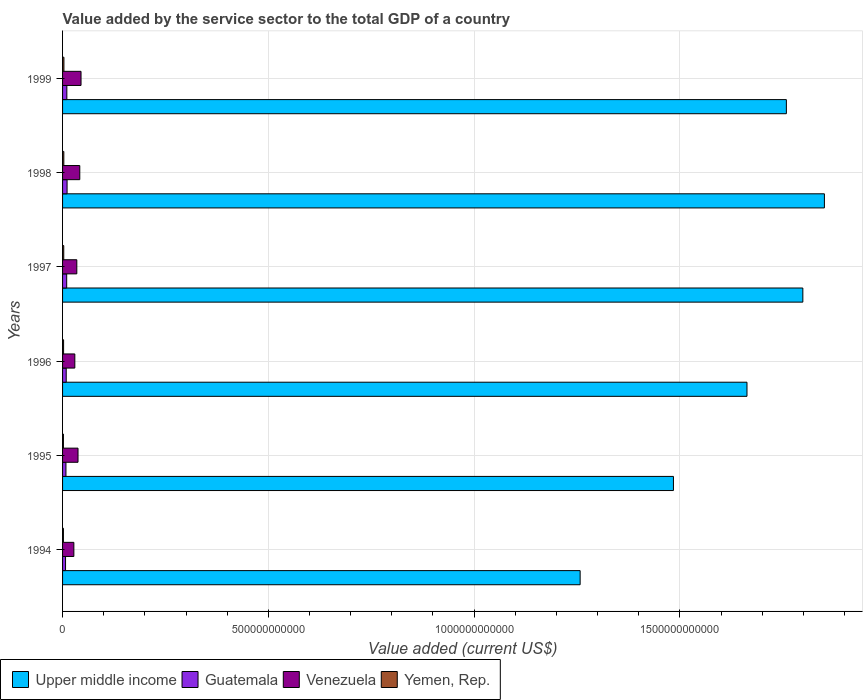Are the number of bars per tick equal to the number of legend labels?
Keep it short and to the point. Yes. What is the value added by the service sector to the total GDP in Venezuela in 1999?
Keep it short and to the point. 4.49e+1. Across all years, what is the maximum value added by the service sector to the total GDP in Guatemala?
Provide a succinct answer. 1.10e+1. Across all years, what is the minimum value added by the service sector to the total GDP in Guatemala?
Give a very brief answer. 7.25e+09. In which year was the value added by the service sector to the total GDP in Upper middle income maximum?
Ensure brevity in your answer.  1998. What is the total value added by the service sector to the total GDP in Yemen, Rep. in the graph?
Provide a short and direct response. 1.59e+1. What is the difference between the value added by the service sector to the total GDP in Yemen, Rep. in 1994 and that in 1996?
Make the answer very short. -4.10e+08. What is the difference between the value added by the service sector to the total GDP in Yemen, Rep. in 1997 and the value added by the service sector to the total GDP in Venezuela in 1999?
Offer a terse response. -4.20e+1. What is the average value added by the service sector to the total GDP in Guatemala per year?
Offer a very short reply. 9.29e+09. In the year 1997, what is the difference between the value added by the service sector to the total GDP in Yemen, Rep. and value added by the service sector to the total GDP in Venezuela?
Make the answer very short. -3.18e+1. In how many years, is the value added by the service sector to the total GDP in Venezuela greater than 1200000000000 US$?
Keep it short and to the point. 0. What is the ratio of the value added by the service sector to the total GDP in Yemen, Rep. in 1996 to that in 1999?
Provide a short and direct response. 0.76. Is the value added by the service sector to the total GDP in Yemen, Rep. in 1996 less than that in 1997?
Give a very brief answer. Yes. What is the difference between the highest and the second highest value added by the service sector to the total GDP in Venezuela?
Make the answer very short. 3.01e+09. What is the difference between the highest and the lowest value added by the service sector to the total GDP in Guatemala?
Provide a short and direct response. 3.72e+09. In how many years, is the value added by the service sector to the total GDP in Guatemala greater than the average value added by the service sector to the total GDP in Guatemala taken over all years?
Make the answer very short. 3. Is it the case that in every year, the sum of the value added by the service sector to the total GDP in Guatemala and value added by the service sector to the total GDP in Yemen, Rep. is greater than the sum of value added by the service sector to the total GDP in Venezuela and value added by the service sector to the total GDP in Upper middle income?
Ensure brevity in your answer.  No. What does the 1st bar from the top in 1999 represents?
Give a very brief answer. Yemen, Rep. What does the 3rd bar from the bottom in 1997 represents?
Provide a short and direct response. Venezuela. Is it the case that in every year, the sum of the value added by the service sector to the total GDP in Upper middle income and value added by the service sector to the total GDP in Yemen, Rep. is greater than the value added by the service sector to the total GDP in Guatemala?
Provide a succinct answer. Yes. How many bars are there?
Your answer should be compact. 24. Are all the bars in the graph horizontal?
Your response must be concise. Yes. How many years are there in the graph?
Make the answer very short. 6. What is the difference between two consecutive major ticks on the X-axis?
Ensure brevity in your answer.  5.00e+11. Are the values on the major ticks of X-axis written in scientific E-notation?
Keep it short and to the point. No. Does the graph contain grids?
Your response must be concise. Yes. How many legend labels are there?
Make the answer very short. 4. What is the title of the graph?
Your response must be concise. Value added by the service sector to the total GDP of a country. What is the label or title of the X-axis?
Provide a succinct answer. Value added (current US$). What is the label or title of the Y-axis?
Make the answer very short. Years. What is the Value added (current US$) of Upper middle income in 1994?
Offer a very short reply. 1.26e+12. What is the Value added (current US$) in Guatemala in 1994?
Give a very brief answer. 7.25e+09. What is the Value added (current US$) in Venezuela in 1994?
Your answer should be very brief. 2.74e+1. What is the Value added (current US$) of Yemen, Rep. in 1994?
Make the answer very short. 2.08e+09. What is the Value added (current US$) in Upper middle income in 1995?
Offer a terse response. 1.48e+12. What is the Value added (current US$) in Guatemala in 1995?
Offer a very short reply. 8.24e+09. What is the Value added (current US$) in Venezuela in 1995?
Offer a terse response. 3.76e+1. What is the Value added (current US$) in Yemen, Rep. in 1995?
Offer a terse response. 2.08e+09. What is the Value added (current US$) in Upper middle income in 1996?
Make the answer very short. 1.66e+12. What is the Value added (current US$) of Guatemala in 1996?
Provide a succinct answer. 8.88e+09. What is the Value added (current US$) in Venezuela in 1996?
Make the answer very short. 2.98e+1. What is the Value added (current US$) in Yemen, Rep. in 1996?
Make the answer very short. 2.49e+09. What is the Value added (current US$) of Upper middle income in 1997?
Your answer should be compact. 1.80e+12. What is the Value added (current US$) in Guatemala in 1997?
Your answer should be very brief. 1.00e+1. What is the Value added (current US$) in Venezuela in 1997?
Ensure brevity in your answer.  3.46e+1. What is the Value added (current US$) in Yemen, Rep. in 1997?
Your answer should be compact. 2.87e+09. What is the Value added (current US$) in Upper middle income in 1998?
Provide a succinct answer. 1.85e+12. What is the Value added (current US$) in Guatemala in 1998?
Provide a succinct answer. 1.10e+1. What is the Value added (current US$) in Venezuela in 1998?
Make the answer very short. 4.18e+1. What is the Value added (current US$) of Yemen, Rep. in 1998?
Keep it short and to the point. 3.06e+09. What is the Value added (current US$) in Upper middle income in 1999?
Keep it short and to the point. 1.76e+12. What is the Value added (current US$) of Guatemala in 1999?
Offer a terse response. 1.04e+1. What is the Value added (current US$) in Venezuela in 1999?
Keep it short and to the point. 4.49e+1. What is the Value added (current US$) in Yemen, Rep. in 1999?
Your answer should be compact. 3.28e+09. Across all years, what is the maximum Value added (current US$) of Upper middle income?
Your answer should be very brief. 1.85e+12. Across all years, what is the maximum Value added (current US$) of Guatemala?
Your answer should be compact. 1.10e+1. Across all years, what is the maximum Value added (current US$) of Venezuela?
Provide a succinct answer. 4.49e+1. Across all years, what is the maximum Value added (current US$) of Yemen, Rep.?
Make the answer very short. 3.28e+09. Across all years, what is the minimum Value added (current US$) in Upper middle income?
Offer a very short reply. 1.26e+12. Across all years, what is the minimum Value added (current US$) in Guatemala?
Your response must be concise. 7.25e+09. Across all years, what is the minimum Value added (current US$) in Venezuela?
Keep it short and to the point. 2.74e+1. Across all years, what is the minimum Value added (current US$) in Yemen, Rep.?
Keep it short and to the point. 2.08e+09. What is the total Value added (current US$) of Upper middle income in the graph?
Offer a terse response. 9.81e+12. What is the total Value added (current US$) in Guatemala in the graph?
Your answer should be very brief. 5.58e+1. What is the total Value added (current US$) in Venezuela in the graph?
Your answer should be compact. 2.16e+11. What is the total Value added (current US$) in Yemen, Rep. in the graph?
Your answer should be compact. 1.59e+1. What is the difference between the Value added (current US$) of Upper middle income in 1994 and that in 1995?
Provide a short and direct response. -2.27e+11. What is the difference between the Value added (current US$) in Guatemala in 1994 and that in 1995?
Your answer should be very brief. -9.87e+08. What is the difference between the Value added (current US$) in Venezuela in 1994 and that in 1995?
Make the answer very short. -1.01e+1. What is the difference between the Value added (current US$) in Yemen, Rep. in 1994 and that in 1995?
Your answer should be very brief. -3.26e+06. What is the difference between the Value added (current US$) in Upper middle income in 1994 and that in 1996?
Offer a terse response. -4.05e+11. What is the difference between the Value added (current US$) of Guatemala in 1994 and that in 1996?
Make the answer very short. -1.63e+09. What is the difference between the Value added (current US$) of Venezuela in 1994 and that in 1996?
Keep it short and to the point. -2.36e+09. What is the difference between the Value added (current US$) in Yemen, Rep. in 1994 and that in 1996?
Give a very brief answer. -4.10e+08. What is the difference between the Value added (current US$) in Upper middle income in 1994 and that in 1997?
Give a very brief answer. -5.41e+11. What is the difference between the Value added (current US$) of Guatemala in 1994 and that in 1997?
Offer a very short reply. -2.77e+09. What is the difference between the Value added (current US$) of Venezuela in 1994 and that in 1997?
Offer a terse response. -7.21e+09. What is the difference between the Value added (current US$) in Yemen, Rep. in 1994 and that in 1997?
Your response must be concise. -7.89e+08. What is the difference between the Value added (current US$) in Upper middle income in 1994 and that in 1998?
Your answer should be compact. -5.94e+11. What is the difference between the Value added (current US$) of Guatemala in 1994 and that in 1998?
Your answer should be compact. -3.72e+09. What is the difference between the Value added (current US$) in Venezuela in 1994 and that in 1998?
Offer a terse response. -1.44e+1. What is the difference between the Value added (current US$) in Yemen, Rep. in 1994 and that in 1998?
Your response must be concise. -9.82e+08. What is the difference between the Value added (current US$) of Upper middle income in 1994 and that in 1999?
Ensure brevity in your answer.  -5.01e+11. What is the difference between the Value added (current US$) of Guatemala in 1994 and that in 1999?
Make the answer very short. -3.16e+09. What is the difference between the Value added (current US$) in Venezuela in 1994 and that in 1999?
Your response must be concise. -1.74e+1. What is the difference between the Value added (current US$) in Yemen, Rep. in 1994 and that in 1999?
Your answer should be very brief. -1.20e+09. What is the difference between the Value added (current US$) in Upper middle income in 1995 and that in 1996?
Keep it short and to the point. -1.79e+11. What is the difference between the Value added (current US$) of Guatemala in 1995 and that in 1996?
Give a very brief answer. -6.43e+08. What is the difference between the Value added (current US$) of Venezuela in 1995 and that in 1996?
Your answer should be very brief. 7.78e+09. What is the difference between the Value added (current US$) of Yemen, Rep. in 1995 and that in 1996?
Make the answer very short. -4.07e+08. What is the difference between the Value added (current US$) of Upper middle income in 1995 and that in 1997?
Provide a succinct answer. -3.14e+11. What is the difference between the Value added (current US$) of Guatemala in 1995 and that in 1997?
Give a very brief answer. -1.78e+09. What is the difference between the Value added (current US$) in Venezuela in 1995 and that in 1997?
Make the answer very short. 2.93e+09. What is the difference between the Value added (current US$) of Yemen, Rep. in 1995 and that in 1997?
Provide a succinct answer. -7.86e+08. What is the difference between the Value added (current US$) of Upper middle income in 1995 and that in 1998?
Make the answer very short. -3.67e+11. What is the difference between the Value added (current US$) in Guatemala in 1995 and that in 1998?
Offer a very short reply. -2.73e+09. What is the difference between the Value added (current US$) of Venezuela in 1995 and that in 1998?
Ensure brevity in your answer.  -4.28e+09. What is the difference between the Value added (current US$) of Yemen, Rep. in 1995 and that in 1998?
Your response must be concise. -9.78e+08. What is the difference between the Value added (current US$) of Upper middle income in 1995 and that in 1999?
Your response must be concise. -2.74e+11. What is the difference between the Value added (current US$) of Guatemala in 1995 and that in 1999?
Give a very brief answer. -2.17e+09. What is the difference between the Value added (current US$) of Venezuela in 1995 and that in 1999?
Make the answer very short. -7.29e+09. What is the difference between the Value added (current US$) of Yemen, Rep. in 1995 and that in 1999?
Ensure brevity in your answer.  -1.20e+09. What is the difference between the Value added (current US$) in Upper middle income in 1996 and that in 1997?
Your answer should be compact. -1.36e+11. What is the difference between the Value added (current US$) in Guatemala in 1996 and that in 1997?
Your response must be concise. -1.14e+09. What is the difference between the Value added (current US$) of Venezuela in 1996 and that in 1997?
Provide a short and direct response. -4.85e+09. What is the difference between the Value added (current US$) in Yemen, Rep. in 1996 and that in 1997?
Ensure brevity in your answer.  -3.79e+08. What is the difference between the Value added (current US$) of Upper middle income in 1996 and that in 1998?
Offer a very short reply. -1.88e+11. What is the difference between the Value added (current US$) in Guatemala in 1996 and that in 1998?
Offer a terse response. -2.09e+09. What is the difference between the Value added (current US$) in Venezuela in 1996 and that in 1998?
Offer a terse response. -1.21e+1. What is the difference between the Value added (current US$) in Yemen, Rep. in 1996 and that in 1998?
Offer a very short reply. -5.72e+08. What is the difference between the Value added (current US$) of Upper middle income in 1996 and that in 1999?
Your answer should be very brief. -9.57e+1. What is the difference between the Value added (current US$) of Guatemala in 1996 and that in 1999?
Provide a short and direct response. -1.53e+09. What is the difference between the Value added (current US$) in Venezuela in 1996 and that in 1999?
Provide a succinct answer. -1.51e+1. What is the difference between the Value added (current US$) of Yemen, Rep. in 1996 and that in 1999?
Ensure brevity in your answer.  -7.93e+08. What is the difference between the Value added (current US$) in Upper middle income in 1997 and that in 1998?
Keep it short and to the point. -5.24e+1. What is the difference between the Value added (current US$) of Guatemala in 1997 and that in 1998?
Your answer should be compact. -9.55e+08. What is the difference between the Value added (current US$) in Venezuela in 1997 and that in 1998?
Provide a short and direct response. -7.21e+09. What is the difference between the Value added (current US$) in Yemen, Rep. in 1997 and that in 1998?
Your answer should be very brief. -1.93e+08. What is the difference between the Value added (current US$) of Upper middle income in 1997 and that in 1999?
Provide a succinct answer. 4.00e+1. What is the difference between the Value added (current US$) in Guatemala in 1997 and that in 1999?
Your answer should be very brief. -3.96e+08. What is the difference between the Value added (current US$) of Venezuela in 1997 and that in 1999?
Provide a succinct answer. -1.02e+1. What is the difference between the Value added (current US$) of Yemen, Rep. in 1997 and that in 1999?
Your response must be concise. -4.14e+08. What is the difference between the Value added (current US$) of Upper middle income in 1998 and that in 1999?
Offer a terse response. 9.24e+1. What is the difference between the Value added (current US$) of Guatemala in 1998 and that in 1999?
Provide a short and direct response. 5.60e+08. What is the difference between the Value added (current US$) in Venezuela in 1998 and that in 1999?
Your response must be concise. -3.01e+09. What is the difference between the Value added (current US$) of Yemen, Rep. in 1998 and that in 1999?
Offer a terse response. -2.22e+08. What is the difference between the Value added (current US$) in Upper middle income in 1994 and the Value added (current US$) in Guatemala in 1995?
Your answer should be compact. 1.25e+12. What is the difference between the Value added (current US$) of Upper middle income in 1994 and the Value added (current US$) of Venezuela in 1995?
Offer a very short reply. 1.22e+12. What is the difference between the Value added (current US$) in Upper middle income in 1994 and the Value added (current US$) in Yemen, Rep. in 1995?
Your answer should be compact. 1.26e+12. What is the difference between the Value added (current US$) of Guatemala in 1994 and the Value added (current US$) of Venezuela in 1995?
Your response must be concise. -3.03e+1. What is the difference between the Value added (current US$) of Guatemala in 1994 and the Value added (current US$) of Yemen, Rep. in 1995?
Offer a very short reply. 5.17e+09. What is the difference between the Value added (current US$) in Venezuela in 1994 and the Value added (current US$) in Yemen, Rep. in 1995?
Provide a succinct answer. 2.53e+1. What is the difference between the Value added (current US$) in Upper middle income in 1994 and the Value added (current US$) in Guatemala in 1996?
Ensure brevity in your answer.  1.25e+12. What is the difference between the Value added (current US$) of Upper middle income in 1994 and the Value added (current US$) of Venezuela in 1996?
Give a very brief answer. 1.23e+12. What is the difference between the Value added (current US$) of Upper middle income in 1994 and the Value added (current US$) of Yemen, Rep. in 1996?
Offer a very short reply. 1.26e+12. What is the difference between the Value added (current US$) in Guatemala in 1994 and the Value added (current US$) in Venezuela in 1996?
Make the answer very short. -2.25e+1. What is the difference between the Value added (current US$) of Guatemala in 1994 and the Value added (current US$) of Yemen, Rep. in 1996?
Your answer should be very brief. 4.76e+09. What is the difference between the Value added (current US$) in Venezuela in 1994 and the Value added (current US$) in Yemen, Rep. in 1996?
Provide a short and direct response. 2.49e+1. What is the difference between the Value added (current US$) of Upper middle income in 1994 and the Value added (current US$) of Guatemala in 1997?
Offer a terse response. 1.25e+12. What is the difference between the Value added (current US$) of Upper middle income in 1994 and the Value added (current US$) of Venezuela in 1997?
Keep it short and to the point. 1.22e+12. What is the difference between the Value added (current US$) in Upper middle income in 1994 and the Value added (current US$) in Yemen, Rep. in 1997?
Give a very brief answer. 1.25e+12. What is the difference between the Value added (current US$) of Guatemala in 1994 and the Value added (current US$) of Venezuela in 1997?
Your response must be concise. -2.74e+1. What is the difference between the Value added (current US$) of Guatemala in 1994 and the Value added (current US$) of Yemen, Rep. in 1997?
Ensure brevity in your answer.  4.38e+09. What is the difference between the Value added (current US$) of Venezuela in 1994 and the Value added (current US$) of Yemen, Rep. in 1997?
Make the answer very short. 2.46e+1. What is the difference between the Value added (current US$) of Upper middle income in 1994 and the Value added (current US$) of Guatemala in 1998?
Provide a short and direct response. 1.25e+12. What is the difference between the Value added (current US$) in Upper middle income in 1994 and the Value added (current US$) in Venezuela in 1998?
Ensure brevity in your answer.  1.22e+12. What is the difference between the Value added (current US$) in Upper middle income in 1994 and the Value added (current US$) in Yemen, Rep. in 1998?
Make the answer very short. 1.25e+12. What is the difference between the Value added (current US$) of Guatemala in 1994 and the Value added (current US$) of Venezuela in 1998?
Your answer should be compact. -3.46e+1. What is the difference between the Value added (current US$) in Guatemala in 1994 and the Value added (current US$) in Yemen, Rep. in 1998?
Offer a very short reply. 4.19e+09. What is the difference between the Value added (current US$) of Venezuela in 1994 and the Value added (current US$) of Yemen, Rep. in 1998?
Keep it short and to the point. 2.44e+1. What is the difference between the Value added (current US$) in Upper middle income in 1994 and the Value added (current US$) in Guatemala in 1999?
Give a very brief answer. 1.25e+12. What is the difference between the Value added (current US$) of Upper middle income in 1994 and the Value added (current US$) of Venezuela in 1999?
Offer a very short reply. 1.21e+12. What is the difference between the Value added (current US$) of Upper middle income in 1994 and the Value added (current US$) of Yemen, Rep. in 1999?
Give a very brief answer. 1.25e+12. What is the difference between the Value added (current US$) of Guatemala in 1994 and the Value added (current US$) of Venezuela in 1999?
Make the answer very short. -3.76e+1. What is the difference between the Value added (current US$) in Guatemala in 1994 and the Value added (current US$) in Yemen, Rep. in 1999?
Offer a very short reply. 3.97e+09. What is the difference between the Value added (current US$) of Venezuela in 1994 and the Value added (current US$) of Yemen, Rep. in 1999?
Your answer should be very brief. 2.41e+1. What is the difference between the Value added (current US$) of Upper middle income in 1995 and the Value added (current US$) of Guatemala in 1996?
Make the answer very short. 1.48e+12. What is the difference between the Value added (current US$) of Upper middle income in 1995 and the Value added (current US$) of Venezuela in 1996?
Your response must be concise. 1.45e+12. What is the difference between the Value added (current US$) in Upper middle income in 1995 and the Value added (current US$) in Yemen, Rep. in 1996?
Provide a short and direct response. 1.48e+12. What is the difference between the Value added (current US$) in Guatemala in 1995 and the Value added (current US$) in Venezuela in 1996?
Give a very brief answer. -2.15e+1. What is the difference between the Value added (current US$) in Guatemala in 1995 and the Value added (current US$) in Yemen, Rep. in 1996?
Your answer should be very brief. 5.75e+09. What is the difference between the Value added (current US$) of Venezuela in 1995 and the Value added (current US$) of Yemen, Rep. in 1996?
Provide a short and direct response. 3.51e+1. What is the difference between the Value added (current US$) in Upper middle income in 1995 and the Value added (current US$) in Guatemala in 1997?
Give a very brief answer. 1.47e+12. What is the difference between the Value added (current US$) of Upper middle income in 1995 and the Value added (current US$) of Venezuela in 1997?
Your response must be concise. 1.45e+12. What is the difference between the Value added (current US$) in Upper middle income in 1995 and the Value added (current US$) in Yemen, Rep. in 1997?
Offer a very short reply. 1.48e+12. What is the difference between the Value added (current US$) of Guatemala in 1995 and the Value added (current US$) of Venezuela in 1997?
Keep it short and to the point. -2.64e+1. What is the difference between the Value added (current US$) in Guatemala in 1995 and the Value added (current US$) in Yemen, Rep. in 1997?
Give a very brief answer. 5.37e+09. What is the difference between the Value added (current US$) of Venezuela in 1995 and the Value added (current US$) of Yemen, Rep. in 1997?
Your response must be concise. 3.47e+1. What is the difference between the Value added (current US$) of Upper middle income in 1995 and the Value added (current US$) of Guatemala in 1998?
Your answer should be very brief. 1.47e+12. What is the difference between the Value added (current US$) in Upper middle income in 1995 and the Value added (current US$) in Venezuela in 1998?
Your response must be concise. 1.44e+12. What is the difference between the Value added (current US$) of Upper middle income in 1995 and the Value added (current US$) of Yemen, Rep. in 1998?
Offer a very short reply. 1.48e+12. What is the difference between the Value added (current US$) of Guatemala in 1995 and the Value added (current US$) of Venezuela in 1998?
Make the answer very short. -3.36e+1. What is the difference between the Value added (current US$) of Guatemala in 1995 and the Value added (current US$) of Yemen, Rep. in 1998?
Your response must be concise. 5.17e+09. What is the difference between the Value added (current US$) in Venezuela in 1995 and the Value added (current US$) in Yemen, Rep. in 1998?
Your response must be concise. 3.45e+1. What is the difference between the Value added (current US$) in Upper middle income in 1995 and the Value added (current US$) in Guatemala in 1999?
Your answer should be very brief. 1.47e+12. What is the difference between the Value added (current US$) in Upper middle income in 1995 and the Value added (current US$) in Venezuela in 1999?
Make the answer very short. 1.44e+12. What is the difference between the Value added (current US$) of Upper middle income in 1995 and the Value added (current US$) of Yemen, Rep. in 1999?
Give a very brief answer. 1.48e+12. What is the difference between the Value added (current US$) of Guatemala in 1995 and the Value added (current US$) of Venezuela in 1999?
Your answer should be very brief. -3.66e+1. What is the difference between the Value added (current US$) in Guatemala in 1995 and the Value added (current US$) in Yemen, Rep. in 1999?
Give a very brief answer. 4.95e+09. What is the difference between the Value added (current US$) of Venezuela in 1995 and the Value added (current US$) of Yemen, Rep. in 1999?
Make the answer very short. 3.43e+1. What is the difference between the Value added (current US$) of Upper middle income in 1996 and the Value added (current US$) of Guatemala in 1997?
Provide a succinct answer. 1.65e+12. What is the difference between the Value added (current US$) of Upper middle income in 1996 and the Value added (current US$) of Venezuela in 1997?
Make the answer very short. 1.63e+12. What is the difference between the Value added (current US$) in Upper middle income in 1996 and the Value added (current US$) in Yemen, Rep. in 1997?
Your response must be concise. 1.66e+12. What is the difference between the Value added (current US$) in Guatemala in 1996 and the Value added (current US$) in Venezuela in 1997?
Give a very brief answer. -2.58e+1. What is the difference between the Value added (current US$) of Guatemala in 1996 and the Value added (current US$) of Yemen, Rep. in 1997?
Your response must be concise. 6.01e+09. What is the difference between the Value added (current US$) in Venezuela in 1996 and the Value added (current US$) in Yemen, Rep. in 1997?
Your answer should be compact. 2.69e+1. What is the difference between the Value added (current US$) in Upper middle income in 1996 and the Value added (current US$) in Guatemala in 1998?
Offer a very short reply. 1.65e+12. What is the difference between the Value added (current US$) of Upper middle income in 1996 and the Value added (current US$) of Venezuela in 1998?
Offer a terse response. 1.62e+12. What is the difference between the Value added (current US$) in Upper middle income in 1996 and the Value added (current US$) in Yemen, Rep. in 1998?
Give a very brief answer. 1.66e+12. What is the difference between the Value added (current US$) of Guatemala in 1996 and the Value added (current US$) of Venezuela in 1998?
Your answer should be very brief. -3.30e+1. What is the difference between the Value added (current US$) in Guatemala in 1996 and the Value added (current US$) in Yemen, Rep. in 1998?
Offer a terse response. 5.82e+09. What is the difference between the Value added (current US$) of Venezuela in 1996 and the Value added (current US$) of Yemen, Rep. in 1998?
Offer a terse response. 2.67e+1. What is the difference between the Value added (current US$) in Upper middle income in 1996 and the Value added (current US$) in Guatemala in 1999?
Provide a succinct answer. 1.65e+12. What is the difference between the Value added (current US$) of Upper middle income in 1996 and the Value added (current US$) of Venezuela in 1999?
Offer a terse response. 1.62e+12. What is the difference between the Value added (current US$) in Upper middle income in 1996 and the Value added (current US$) in Yemen, Rep. in 1999?
Your response must be concise. 1.66e+12. What is the difference between the Value added (current US$) of Guatemala in 1996 and the Value added (current US$) of Venezuela in 1999?
Provide a short and direct response. -3.60e+1. What is the difference between the Value added (current US$) of Guatemala in 1996 and the Value added (current US$) of Yemen, Rep. in 1999?
Offer a very short reply. 5.60e+09. What is the difference between the Value added (current US$) in Venezuela in 1996 and the Value added (current US$) in Yemen, Rep. in 1999?
Your response must be concise. 2.65e+1. What is the difference between the Value added (current US$) in Upper middle income in 1997 and the Value added (current US$) in Guatemala in 1998?
Keep it short and to the point. 1.79e+12. What is the difference between the Value added (current US$) in Upper middle income in 1997 and the Value added (current US$) in Venezuela in 1998?
Provide a short and direct response. 1.76e+12. What is the difference between the Value added (current US$) in Upper middle income in 1997 and the Value added (current US$) in Yemen, Rep. in 1998?
Provide a short and direct response. 1.80e+12. What is the difference between the Value added (current US$) of Guatemala in 1997 and the Value added (current US$) of Venezuela in 1998?
Provide a short and direct response. -3.18e+1. What is the difference between the Value added (current US$) in Guatemala in 1997 and the Value added (current US$) in Yemen, Rep. in 1998?
Offer a very short reply. 6.95e+09. What is the difference between the Value added (current US$) in Venezuela in 1997 and the Value added (current US$) in Yemen, Rep. in 1998?
Your answer should be compact. 3.16e+1. What is the difference between the Value added (current US$) of Upper middle income in 1997 and the Value added (current US$) of Guatemala in 1999?
Your answer should be very brief. 1.79e+12. What is the difference between the Value added (current US$) in Upper middle income in 1997 and the Value added (current US$) in Venezuela in 1999?
Give a very brief answer. 1.75e+12. What is the difference between the Value added (current US$) of Upper middle income in 1997 and the Value added (current US$) of Yemen, Rep. in 1999?
Make the answer very short. 1.80e+12. What is the difference between the Value added (current US$) of Guatemala in 1997 and the Value added (current US$) of Venezuela in 1999?
Keep it short and to the point. -3.48e+1. What is the difference between the Value added (current US$) in Guatemala in 1997 and the Value added (current US$) in Yemen, Rep. in 1999?
Provide a succinct answer. 6.73e+09. What is the difference between the Value added (current US$) in Venezuela in 1997 and the Value added (current US$) in Yemen, Rep. in 1999?
Your answer should be very brief. 3.13e+1. What is the difference between the Value added (current US$) in Upper middle income in 1998 and the Value added (current US$) in Guatemala in 1999?
Offer a terse response. 1.84e+12. What is the difference between the Value added (current US$) of Upper middle income in 1998 and the Value added (current US$) of Venezuela in 1999?
Your answer should be very brief. 1.81e+12. What is the difference between the Value added (current US$) of Upper middle income in 1998 and the Value added (current US$) of Yemen, Rep. in 1999?
Ensure brevity in your answer.  1.85e+12. What is the difference between the Value added (current US$) of Guatemala in 1998 and the Value added (current US$) of Venezuela in 1999?
Keep it short and to the point. -3.39e+1. What is the difference between the Value added (current US$) of Guatemala in 1998 and the Value added (current US$) of Yemen, Rep. in 1999?
Your answer should be very brief. 7.69e+09. What is the difference between the Value added (current US$) in Venezuela in 1998 and the Value added (current US$) in Yemen, Rep. in 1999?
Offer a very short reply. 3.86e+1. What is the average Value added (current US$) of Upper middle income per year?
Give a very brief answer. 1.64e+12. What is the average Value added (current US$) in Guatemala per year?
Keep it short and to the point. 9.29e+09. What is the average Value added (current US$) of Venezuela per year?
Provide a succinct answer. 3.60e+1. What is the average Value added (current US$) of Yemen, Rep. per year?
Your response must be concise. 2.64e+09. In the year 1994, what is the difference between the Value added (current US$) in Upper middle income and Value added (current US$) in Guatemala?
Your answer should be very brief. 1.25e+12. In the year 1994, what is the difference between the Value added (current US$) in Upper middle income and Value added (current US$) in Venezuela?
Your response must be concise. 1.23e+12. In the year 1994, what is the difference between the Value added (current US$) of Upper middle income and Value added (current US$) of Yemen, Rep.?
Offer a terse response. 1.26e+12. In the year 1994, what is the difference between the Value added (current US$) in Guatemala and Value added (current US$) in Venezuela?
Provide a short and direct response. -2.02e+1. In the year 1994, what is the difference between the Value added (current US$) of Guatemala and Value added (current US$) of Yemen, Rep.?
Make the answer very short. 5.17e+09. In the year 1994, what is the difference between the Value added (current US$) of Venezuela and Value added (current US$) of Yemen, Rep.?
Make the answer very short. 2.53e+1. In the year 1995, what is the difference between the Value added (current US$) in Upper middle income and Value added (current US$) in Guatemala?
Provide a succinct answer. 1.48e+12. In the year 1995, what is the difference between the Value added (current US$) in Upper middle income and Value added (current US$) in Venezuela?
Provide a succinct answer. 1.45e+12. In the year 1995, what is the difference between the Value added (current US$) of Upper middle income and Value added (current US$) of Yemen, Rep.?
Make the answer very short. 1.48e+12. In the year 1995, what is the difference between the Value added (current US$) of Guatemala and Value added (current US$) of Venezuela?
Provide a succinct answer. -2.93e+1. In the year 1995, what is the difference between the Value added (current US$) in Guatemala and Value added (current US$) in Yemen, Rep.?
Offer a very short reply. 6.15e+09. In the year 1995, what is the difference between the Value added (current US$) in Venezuela and Value added (current US$) in Yemen, Rep.?
Ensure brevity in your answer.  3.55e+1. In the year 1996, what is the difference between the Value added (current US$) of Upper middle income and Value added (current US$) of Guatemala?
Provide a succinct answer. 1.65e+12. In the year 1996, what is the difference between the Value added (current US$) in Upper middle income and Value added (current US$) in Venezuela?
Your answer should be compact. 1.63e+12. In the year 1996, what is the difference between the Value added (current US$) of Upper middle income and Value added (current US$) of Yemen, Rep.?
Your response must be concise. 1.66e+12. In the year 1996, what is the difference between the Value added (current US$) in Guatemala and Value added (current US$) in Venezuela?
Your response must be concise. -2.09e+1. In the year 1996, what is the difference between the Value added (current US$) in Guatemala and Value added (current US$) in Yemen, Rep.?
Give a very brief answer. 6.39e+09. In the year 1996, what is the difference between the Value added (current US$) of Venezuela and Value added (current US$) of Yemen, Rep.?
Your response must be concise. 2.73e+1. In the year 1997, what is the difference between the Value added (current US$) in Upper middle income and Value added (current US$) in Guatemala?
Give a very brief answer. 1.79e+12. In the year 1997, what is the difference between the Value added (current US$) in Upper middle income and Value added (current US$) in Venezuela?
Make the answer very short. 1.76e+12. In the year 1997, what is the difference between the Value added (current US$) in Upper middle income and Value added (current US$) in Yemen, Rep.?
Make the answer very short. 1.80e+12. In the year 1997, what is the difference between the Value added (current US$) of Guatemala and Value added (current US$) of Venezuela?
Offer a very short reply. -2.46e+1. In the year 1997, what is the difference between the Value added (current US$) of Guatemala and Value added (current US$) of Yemen, Rep.?
Make the answer very short. 7.15e+09. In the year 1997, what is the difference between the Value added (current US$) in Venezuela and Value added (current US$) in Yemen, Rep.?
Your answer should be compact. 3.18e+1. In the year 1998, what is the difference between the Value added (current US$) of Upper middle income and Value added (current US$) of Guatemala?
Your answer should be compact. 1.84e+12. In the year 1998, what is the difference between the Value added (current US$) of Upper middle income and Value added (current US$) of Venezuela?
Your answer should be very brief. 1.81e+12. In the year 1998, what is the difference between the Value added (current US$) of Upper middle income and Value added (current US$) of Yemen, Rep.?
Ensure brevity in your answer.  1.85e+12. In the year 1998, what is the difference between the Value added (current US$) of Guatemala and Value added (current US$) of Venezuela?
Offer a terse response. -3.09e+1. In the year 1998, what is the difference between the Value added (current US$) in Guatemala and Value added (current US$) in Yemen, Rep.?
Keep it short and to the point. 7.91e+09. In the year 1998, what is the difference between the Value added (current US$) in Venezuela and Value added (current US$) in Yemen, Rep.?
Offer a very short reply. 3.88e+1. In the year 1999, what is the difference between the Value added (current US$) in Upper middle income and Value added (current US$) in Guatemala?
Provide a succinct answer. 1.75e+12. In the year 1999, what is the difference between the Value added (current US$) in Upper middle income and Value added (current US$) in Venezuela?
Your response must be concise. 1.71e+12. In the year 1999, what is the difference between the Value added (current US$) of Upper middle income and Value added (current US$) of Yemen, Rep.?
Provide a succinct answer. 1.76e+12. In the year 1999, what is the difference between the Value added (current US$) of Guatemala and Value added (current US$) of Venezuela?
Ensure brevity in your answer.  -3.44e+1. In the year 1999, what is the difference between the Value added (current US$) of Guatemala and Value added (current US$) of Yemen, Rep.?
Offer a very short reply. 7.13e+09. In the year 1999, what is the difference between the Value added (current US$) of Venezuela and Value added (current US$) of Yemen, Rep.?
Make the answer very short. 4.16e+1. What is the ratio of the Value added (current US$) in Upper middle income in 1994 to that in 1995?
Your response must be concise. 0.85. What is the ratio of the Value added (current US$) of Guatemala in 1994 to that in 1995?
Give a very brief answer. 0.88. What is the ratio of the Value added (current US$) in Venezuela in 1994 to that in 1995?
Offer a very short reply. 0.73. What is the ratio of the Value added (current US$) in Yemen, Rep. in 1994 to that in 1995?
Provide a succinct answer. 1. What is the ratio of the Value added (current US$) of Upper middle income in 1994 to that in 1996?
Offer a very short reply. 0.76. What is the ratio of the Value added (current US$) in Guatemala in 1994 to that in 1996?
Keep it short and to the point. 0.82. What is the ratio of the Value added (current US$) in Venezuela in 1994 to that in 1996?
Keep it short and to the point. 0.92. What is the ratio of the Value added (current US$) of Yemen, Rep. in 1994 to that in 1996?
Keep it short and to the point. 0.84. What is the ratio of the Value added (current US$) of Upper middle income in 1994 to that in 1997?
Your answer should be very brief. 0.7. What is the ratio of the Value added (current US$) of Guatemala in 1994 to that in 1997?
Give a very brief answer. 0.72. What is the ratio of the Value added (current US$) in Venezuela in 1994 to that in 1997?
Provide a succinct answer. 0.79. What is the ratio of the Value added (current US$) of Yemen, Rep. in 1994 to that in 1997?
Your answer should be compact. 0.72. What is the ratio of the Value added (current US$) in Upper middle income in 1994 to that in 1998?
Your response must be concise. 0.68. What is the ratio of the Value added (current US$) of Guatemala in 1994 to that in 1998?
Offer a very short reply. 0.66. What is the ratio of the Value added (current US$) of Venezuela in 1994 to that in 1998?
Give a very brief answer. 0.66. What is the ratio of the Value added (current US$) in Yemen, Rep. in 1994 to that in 1998?
Ensure brevity in your answer.  0.68. What is the ratio of the Value added (current US$) in Upper middle income in 1994 to that in 1999?
Provide a short and direct response. 0.72. What is the ratio of the Value added (current US$) in Guatemala in 1994 to that in 1999?
Give a very brief answer. 0.7. What is the ratio of the Value added (current US$) in Venezuela in 1994 to that in 1999?
Ensure brevity in your answer.  0.61. What is the ratio of the Value added (current US$) of Yemen, Rep. in 1994 to that in 1999?
Ensure brevity in your answer.  0.63. What is the ratio of the Value added (current US$) in Upper middle income in 1995 to that in 1996?
Your answer should be very brief. 0.89. What is the ratio of the Value added (current US$) in Guatemala in 1995 to that in 1996?
Provide a succinct answer. 0.93. What is the ratio of the Value added (current US$) of Venezuela in 1995 to that in 1996?
Make the answer very short. 1.26. What is the ratio of the Value added (current US$) of Yemen, Rep. in 1995 to that in 1996?
Your answer should be compact. 0.84. What is the ratio of the Value added (current US$) of Upper middle income in 1995 to that in 1997?
Offer a terse response. 0.83. What is the ratio of the Value added (current US$) in Guatemala in 1995 to that in 1997?
Offer a very short reply. 0.82. What is the ratio of the Value added (current US$) in Venezuela in 1995 to that in 1997?
Provide a succinct answer. 1.08. What is the ratio of the Value added (current US$) in Yemen, Rep. in 1995 to that in 1997?
Your answer should be very brief. 0.73. What is the ratio of the Value added (current US$) in Upper middle income in 1995 to that in 1998?
Make the answer very short. 0.8. What is the ratio of the Value added (current US$) of Guatemala in 1995 to that in 1998?
Your answer should be very brief. 0.75. What is the ratio of the Value added (current US$) of Venezuela in 1995 to that in 1998?
Give a very brief answer. 0.9. What is the ratio of the Value added (current US$) in Yemen, Rep. in 1995 to that in 1998?
Your response must be concise. 0.68. What is the ratio of the Value added (current US$) in Upper middle income in 1995 to that in 1999?
Ensure brevity in your answer.  0.84. What is the ratio of the Value added (current US$) of Guatemala in 1995 to that in 1999?
Provide a succinct answer. 0.79. What is the ratio of the Value added (current US$) of Venezuela in 1995 to that in 1999?
Offer a very short reply. 0.84. What is the ratio of the Value added (current US$) in Yemen, Rep. in 1995 to that in 1999?
Provide a short and direct response. 0.63. What is the ratio of the Value added (current US$) in Upper middle income in 1996 to that in 1997?
Provide a succinct answer. 0.92. What is the ratio of the Value added (current US$) of Guatemala in 1996 to that in 1997?
Offer a very short reply. 0.89. What is the ratio of the Value added (current US$) in Venezuela in 1996 to that in 1997?
Provide a short and direct response. 0.86. What is the ratio of the Value added (current US$) in Yemen, Rep. in 1996 to that in 1997?
Your response must be concise. 0.87. What is the ratio of the Value added (current US$) of Upper middle income in 1996 to that in 1998?
Provide a succinct answer. 0.9. What is the ratio of the Value added (current US$) of Guatemala in 1996 to that in 1998?
Offer a terse response. 0.81. What is the ratio of the Value added (current US$) in Venezuela in 1996 to that in 1998?
Your answer should be very brief. 0.71. What is the ratio of the Value added (current US$) of Yemen, Rep. in 1996 to that in 1998?
Your answer should be compact. 0.81. What is the ratio of the Value added (current US$) in Upper middle income in 1996 to that in 1999?
Keep it short and to the point. 0.95. What is the ratio of the Value added (current US$) in Guatemala in 1996 to that in 1999?
Keep it short and to the point. 0.85. What is the ratio of the Value added (current US$) of Venezuela in 1996 to that in 1999?
Make the answer very short. 0.66. What is the ratio of the Value added (current US$) in Yemen, Rep. in 1996 to that in 1999?
Make the answer very short. 0.76. What is the ratio of the Value added (current US$) of Upper middle income in 1997 to that in 1998?
Ensure brevity in your answer.  0.97. What is the ratio of the Value added (current US$) in Guatemala in 1997 to that in 1998?
Your answer should be compact. 0.91. What is the ratio of the Value added (current US$) of Venezuela in 1997 to that in 1998?
Provide a short and direct response. 0.83. What is the ratio of the Value added (current US$) in Yemen, Rep. in 1997 to that in 1998?
Make the answer very short. 0.94. What is the ratio of the Value added (current US$) in Upper middle income in 1997 to that in 1999?
Provide a short and direct response. 1.02. What is the ratio of the Value added (current US$) in Venezuela in 1997 to that in 1999?
Your answer should be compact. 0.77. What is the ratio of the Value added (current US$) of Yemen, Rep. in 1997 to that in 1999?
Give a very brief answer. 0.87. What is the ratio of the Value added (current US$) of Upper middle income in 1998 to that in 1999?
Provide a short and direct response. 1.05. What is the ratio of the Value added (current US$) in Guatemala in 1998 to that in 1999?
Give a very brief answer. 1.05. What is the ratio of the Value added (current US$) in Venezuela in 1998 to that in 1999?
Offer a very short reply. 0.93. What is the ratio of the Value added (current US$) in Yemen, Rep. in 1998 to that in 1999?
Your response must be concise. 0.93. What is the difference between the highest and the second highest Value added (current US$) of Upper middle income?
Ensure brevity in your answer.  5.24e+1. What is the difference between the highest and the second highest Value added (current US$) in Guatemala?
Give a very brief answer. 5.60e+08. What is the difference between the highest and the second highest Value added (current US$) in Venezuela?
Keep it short and to the point. 3.01e+09. What is the difference between the highest and the second highest Value added (current US$) in Yemen, Rep.?
Provide a succinct answer. 2.22e+08. What is the difference between the highest and the lowest Value added (current US$) of Upper middle income?
Ensure brevity in your answer.  5.94e+11. What is the difference between the highest and the lowest Value added (current US$) in Guatemala?
Give a very brief answer. 3.72e+09. What is the difference between the highest and the lowest Value added (current US$) of Venezuela?
Make the answer very short. 1.74e+1. What is the difference between the highest and the lowest Value added (current US$) in Yemen, Rep.?
Make the answer very short. 1.20e+09. 